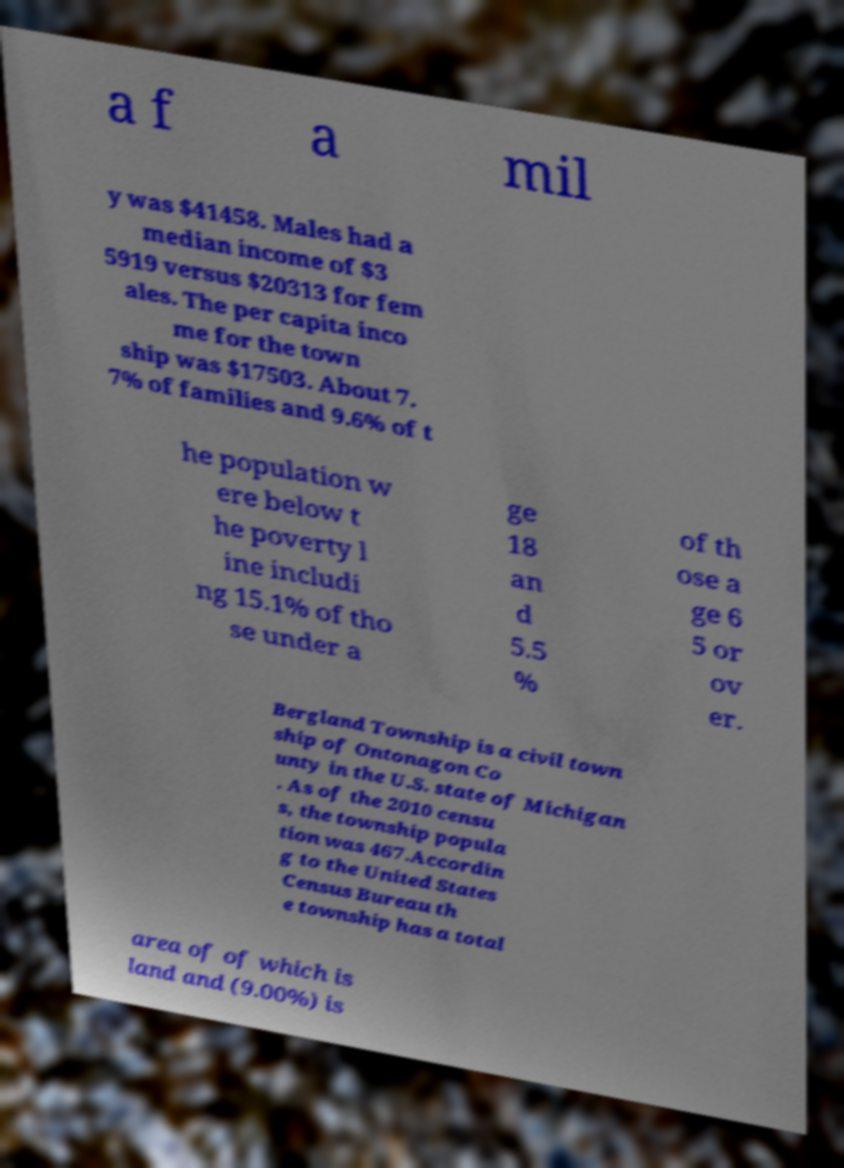What messages or text are displayed in this image? I need them in a readable, typed format. a f a mil y was $41458. Males had a median income of $3 5919 versus $20313 for fem ales. The per capita inco me for the town ship was $17503. About 7. 7% of families and 9.6% of t he population w ere below t he poverty l ine includi ng 15.1% of tho se under a ge 18 an d 5.5 % of th ose a ge 6 5 or ov er. Bergland Township is a civil town ship of Ontonagon Co unty in the U.S. state of Michigan . As of the 2010 censu s, the township popula tion was 467.Accordin g to the United States Census Bureau th e township has a total area of of which is land and (9.00%) is 